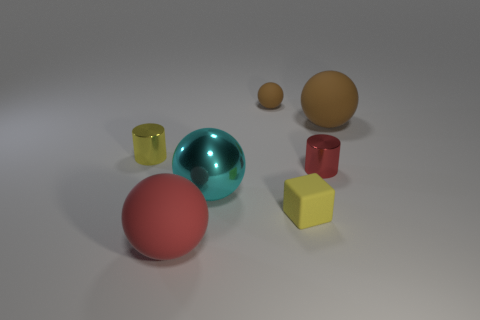Add 2 cyan things. How many objects exist? 9 Subtract all balls. How many objects are left? 3 Subtract all tiny brown spheres. Subtract all yellow objects. How many objects are left? 4 Add 5 red metal things. How many red metal things are left? 6 Add 6 big yellow metallic blocks. How many big yellow metallic blocks exist? 6 Subtract 0 blue spheres. How many objects are left? 7 